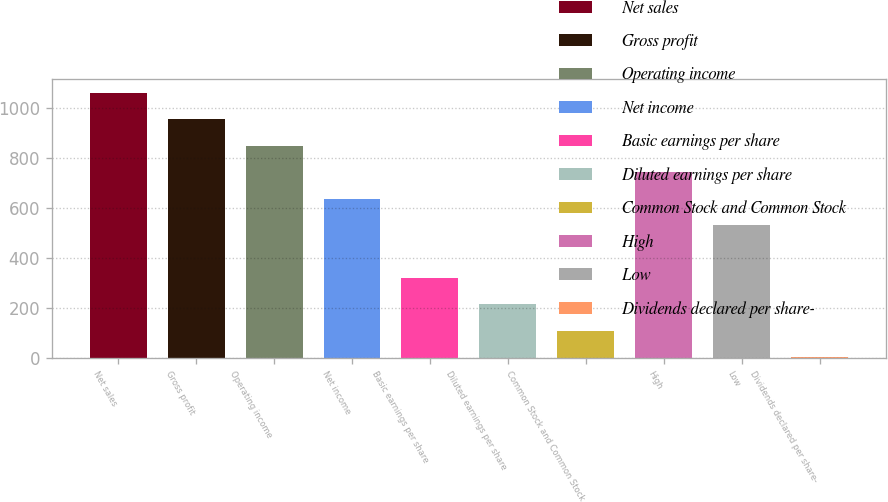Convert chart. <chart><loc_0><loc_0><loc_500><loc_500><bar_chart><fcel>Net sales<fcel>Gross profit<fcel>Operating income<fcel>Net income<fcel>Basic earnings per share<fcel>Diluted earnings per share<fcel>Common Stock and Common Stock<fcel>High<fcel>Low<fcel>Dividends declared per share-<nl><fcel>1063.3<fcel>957.01<fcel>850.72<fcel>638.14<fcel>319.27<fcel>212.98<fcel>106.69<fcel>744.43<fcel>531.85<fcel>0.4<nl></chart> 